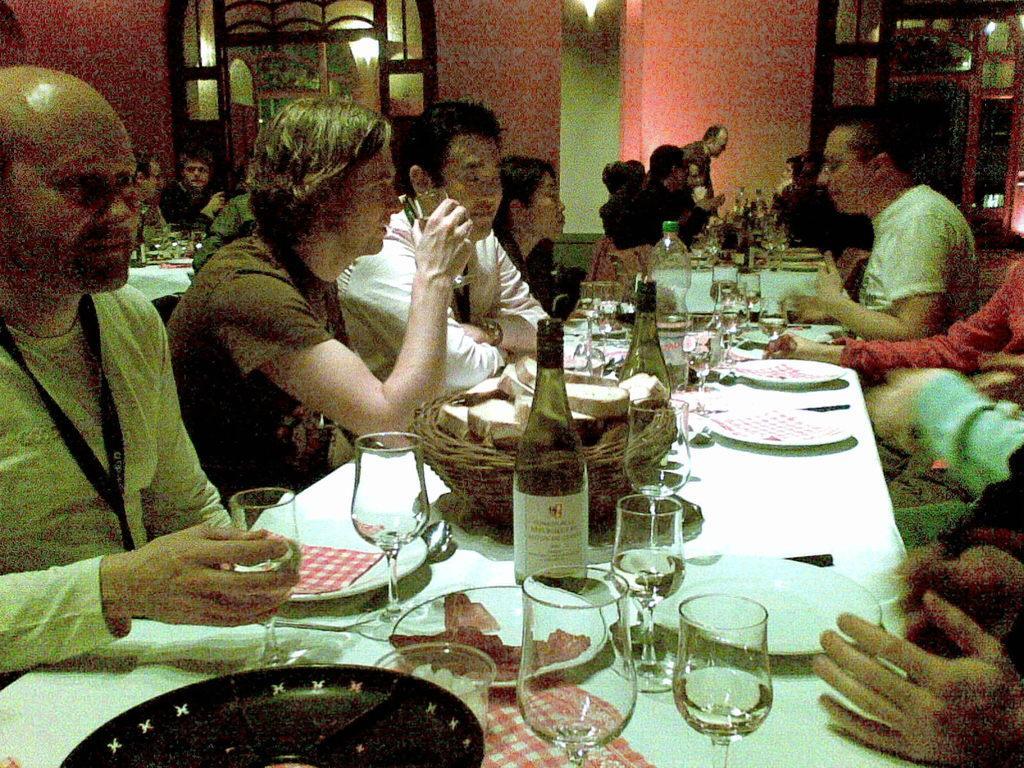Could you give a brief overview of what you see in this image? In the image we can see there are people who are sitting in a chair and in front of them there is a table on which there is a wine bottle and wine glasses and in plate there is a meat and there are lot of people sitting in the room. 